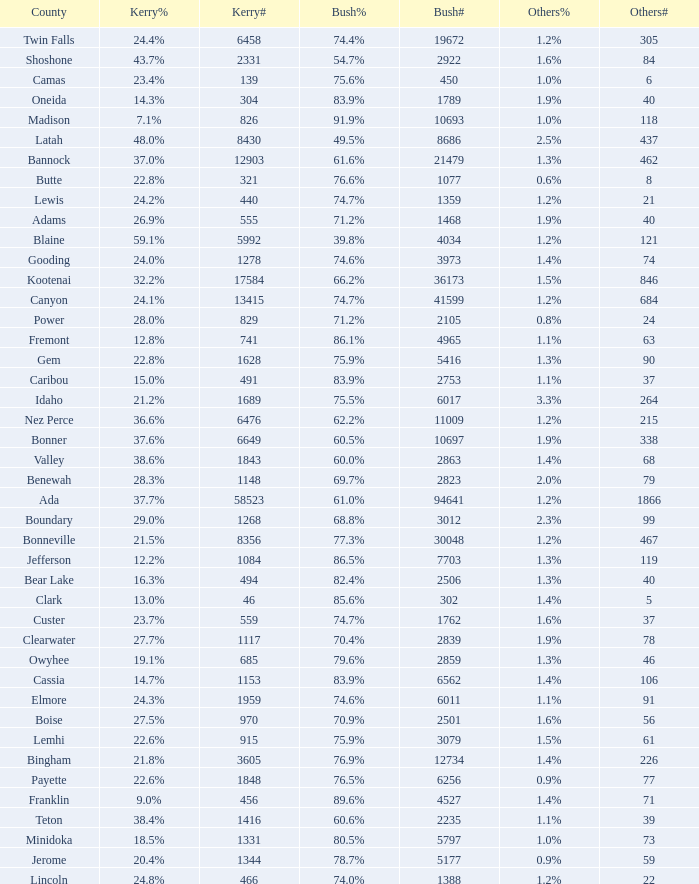What percentage of the people in Bonneville voted for Bush? 77.3%. 